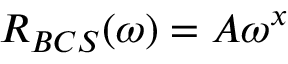<formula> <loc_0><loc_0><loc_500><loc_500>\begin{array} { r } { R _ { B C S } ( \omega ) = A \omega ^ { x } } \end{array}</formula> 